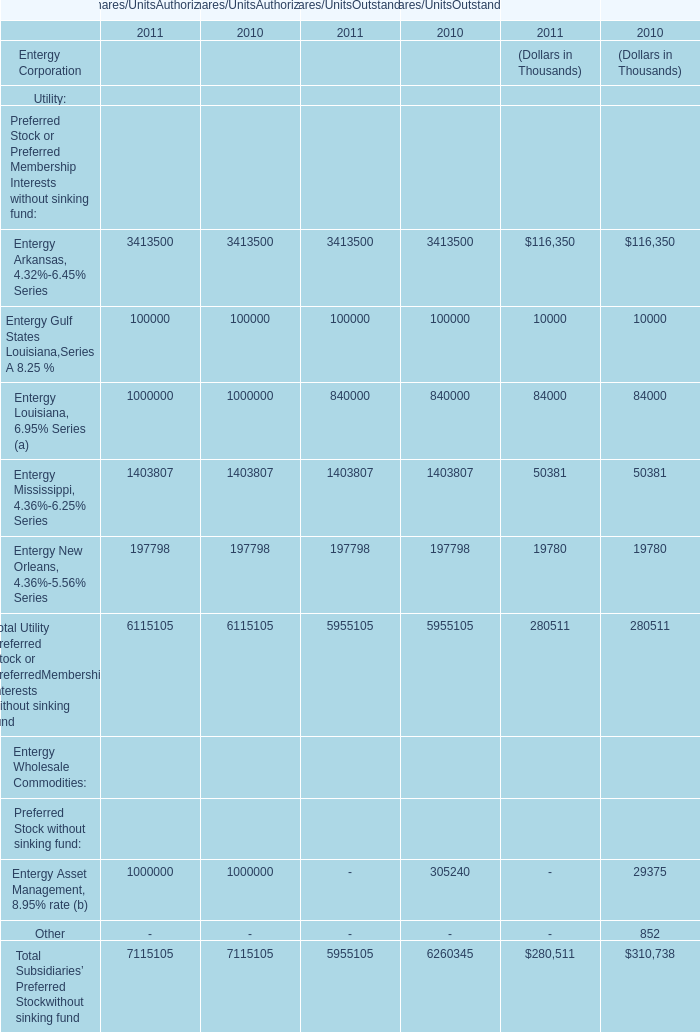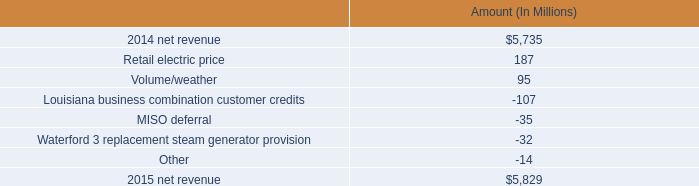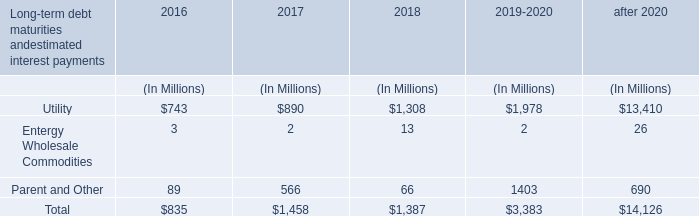What is the sum of Shares/UnitsAuthorized in the range of 0 and 100,001 in 2011? (in Thousand) 
Computations: (100000 + 100000)
Answer: 200000.0. 